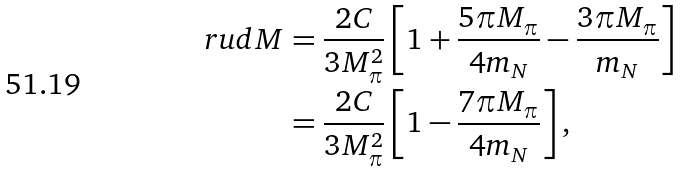<formula> <loc_0><loc_0><loc_500><loc_500>\ r u d { M } & = \frac { 2 C } { 3 M _ { \pi } ^ { 2 } } \left [ 1 + \frac { 5 \pi M _ { \pi } } { 4 m _ { N } } - \frac { 3 \pi M _ { \pi } } { m _ { N } } \right ] \\ & = \frac { 2 C } { 3 M _ { \pi } ^ { 2 } } \left [ 1 - \frac { 7 \pi M _ { \pi } } { 4 m _ { N } } \right ] ,</formula> 